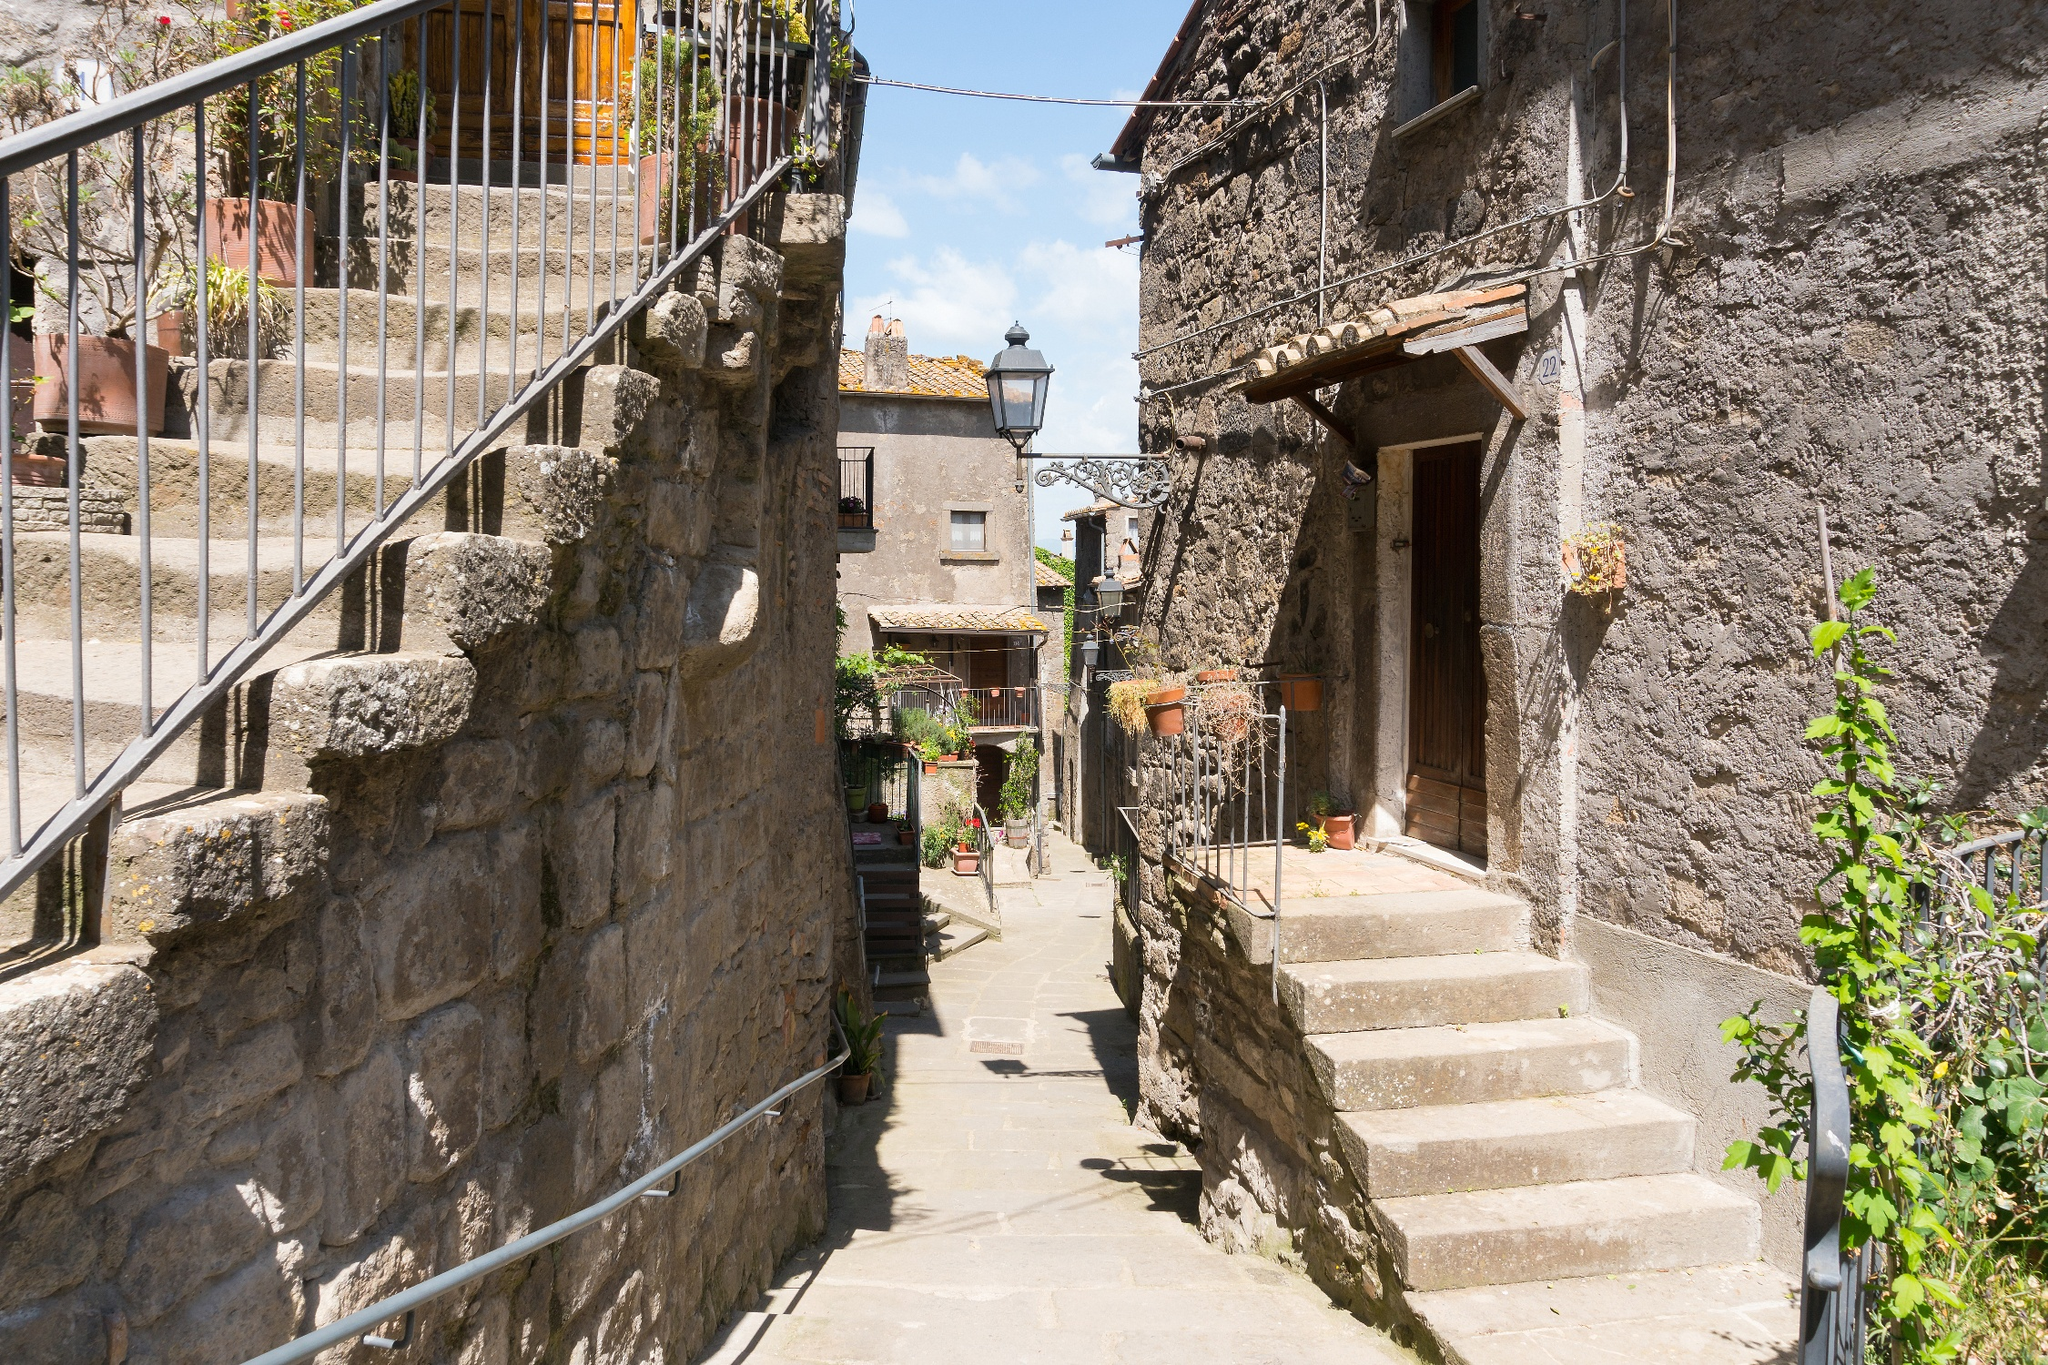What mysterious events might occur in this quiet alleyway at night? In the stillness of night, this quiet alleyway transforms into a realm of mysterious events. The cobblestones, glowing faintly under the moonlight, seem to whisper ancient secrets. Shadows dance along the stone walls, taking on eerie shapes as if hinting at invisible beings frolicking in the night. Lanterns flicker as a cool breeze weaves through the alley, carrying the faint sound of whispers. Occasionally, a figure cloaked in shadow might be seen gliding silently from door to door, leaving behind a trail of luminescent flowers that vanish by dawn. The ivy and plants seem to hum, and on rare nights, the fountain in the courtyard springs to life, its water sparkling with a mysterious, ethereal light. Locals speak of a guardian spirit that roams these streets, protecting the village and keeping its legends alive under the veil of the night. 